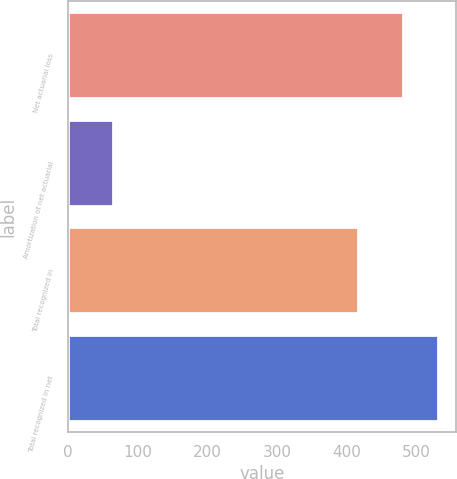Convert chart to OTSL. <chart><loc_0><loc_0><loc_500><loc_500><bar_chart><fcel>Net actuarial loss<fcel>Amortization of net actuarial<fcel>Total recognized in<fcel>Total recognized in net<nl><fcel>481<fcel>65<fcel>416<fcel>530<nl></chart> 